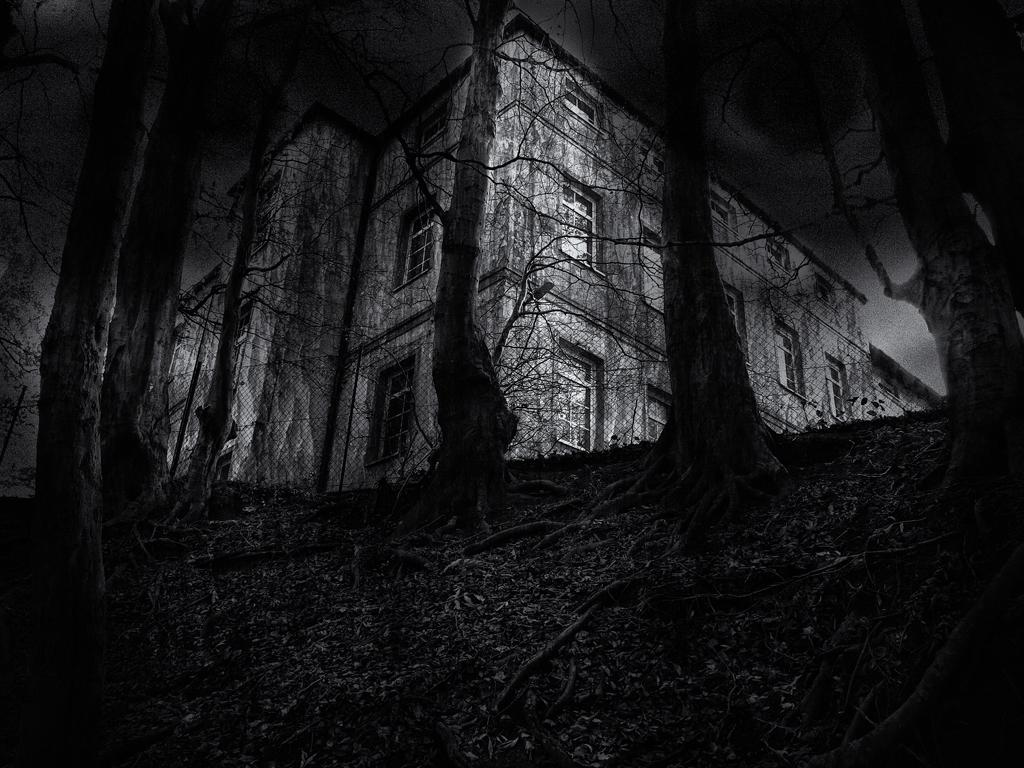What type of vegetation is visible in the front of the image? There are dry trees in the front of the image. What type of structure can be seen in the background of the image? There is a building with windows in the background of the image. How would you describe the sky in the image? The sky is dark in the image. What is the purpose of the kite in the image? There is no kite present in the image. What event is taking place in the image? The image does not depict any specific event; it shows dry trees, a building, and a dark sky. 